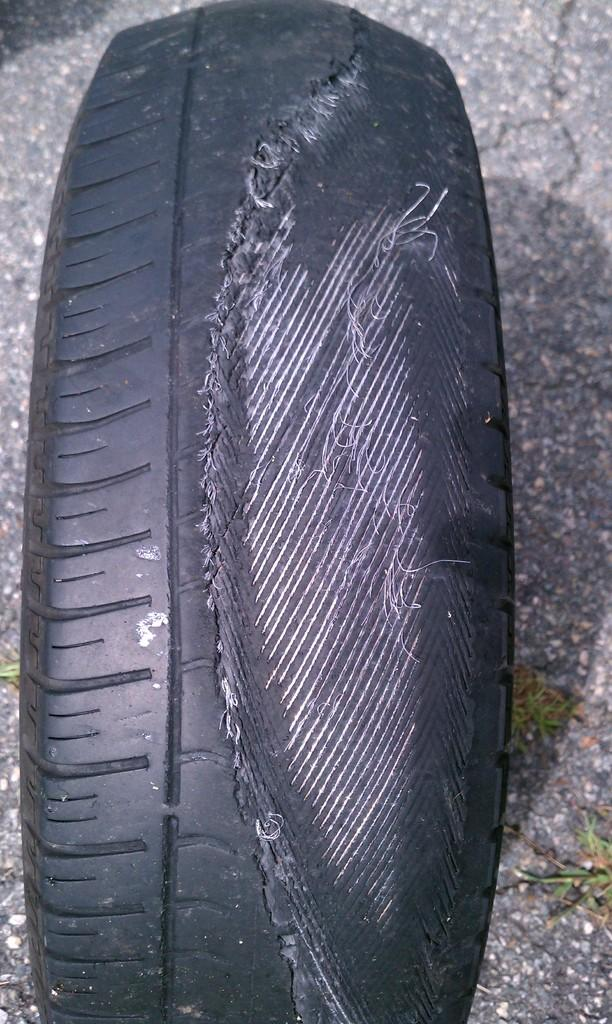What object can be seen in the image? There is a tyre in the image. Is there a butter exchange happening on the bridge in the image? There is no bridge or butter exchange present in the image; it only features a tyre. 